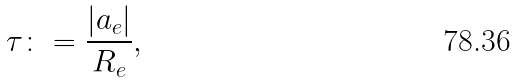Convert formula to latex. <formula><loc_0><loc_0><loc_500><loc_500>\tau \colon = \frac { | a _ { e } | } { R _ { e } } ,</formula> 